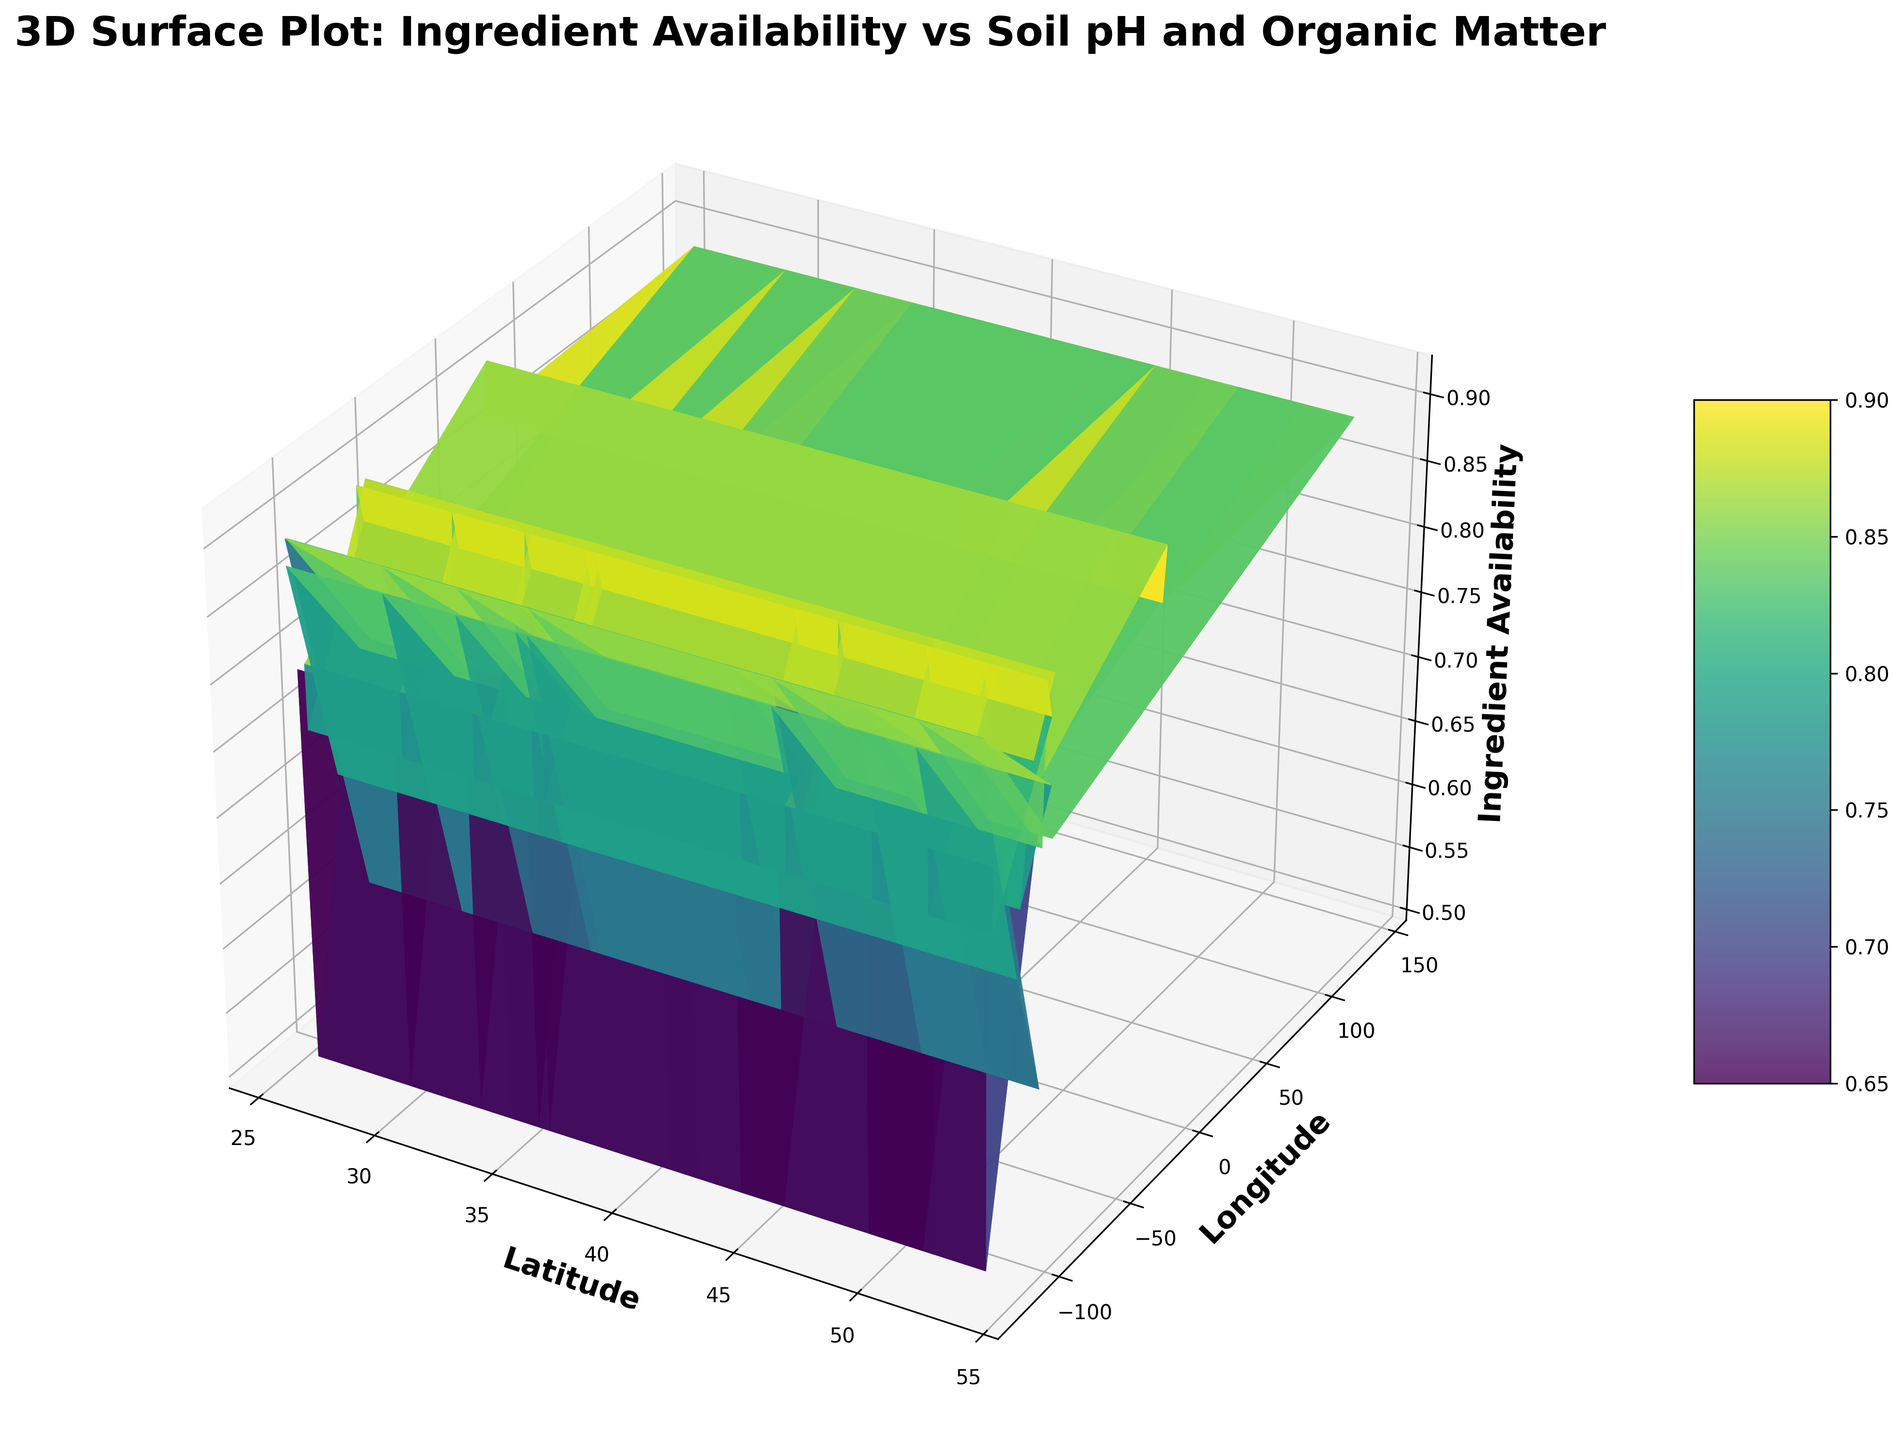What is the correlation between latitude and ingredient availability? We can observe the relation by visually inspecting the 3D surface plot. If the surface slope concerning latitude and ingredient availability is mostly flat or varies gently, the correlation is weak or non-existent. If there is a steep slope, the correlation may be strong.
Answer: Weak Which location (latitude-longitude pair) shows the highest ingredient availability? By looking at the topmost points on the 3D surface plot, we can identify a pair of coordinates with the highest "Z" value, corresponding to ingredient availability.
Answer: 48.85, 2.35 Do locations with higher soil pH tend to show higher or lower ingredient availability? By inspecting the 3D surface where soil pH values are displayed on one axis and ingredient availability on the "Z" axis, we would check if higher pH values correspond to higher or lower points on the surface.
Answer: Lower Is there a visual trend of higher organic matter corresponding to increased ingredient availability? By examining the plot, if we see that higher organic matter values (another potentially marked axis) align with higher points on the 3D surface, then a positive trend exists.
Answer: Yes How does ingredient availability compare between regions with loam soil texture and sandy soil texture? By identifying regions with different soil textures, we can compare their heights on the 3D surface. Regions with loam soil texture should have their ingredient availability points compared with those of sandy soil textures.
Answer: Loam > Sandy Which soil texture type appears to have the most consistent ingredient availability across different latitudes? By observing the variance in ingredient availability values across each soil texture type as plotted on the surface, we can determine which one exhibits the least variability.
Answer: Loam What is the combined effect of low soil pH and high organic matter on ingredient availability at a specific region, say latitude 43.65 and longitude -79.38? This involves observing the height of the surface on the 3D plot at the coordinates where low soil pH (5.4) and high organic matter (6.7) are present.
Answer: High What is the ingredient availability difference between latitudes 40.71 and 40.73 with similar soil pH? In the 3D surface plot, find the ingredient availability values at these latitudes and subtract one from the other to get their difference.
Answer: 0.9 - 0.78 = 0.12 At what latitude-longitude combination does the soil pH of around 6.0 show a significant ingredient availability value? Trace soil pH around 6.0 on the plot and note the latitude and longitude where the 3D surface peaks in ingredient availability.
Answer: 41.88, -87.63 